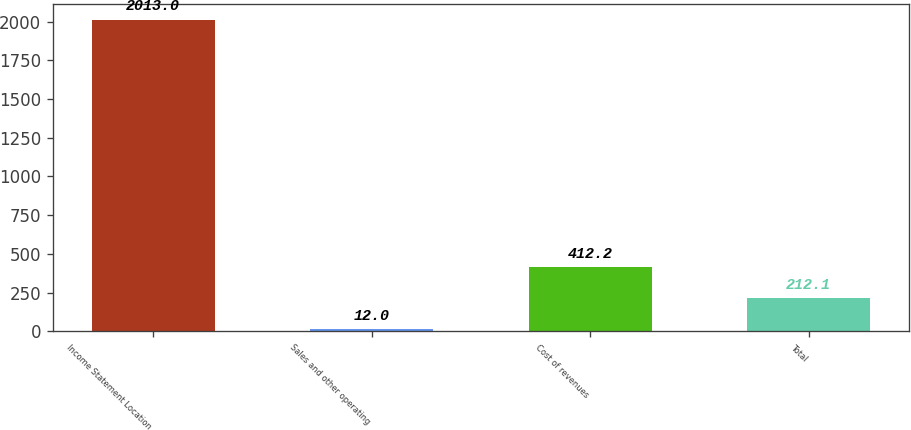Convert chart. <chart><loc_0><loc_0><loc_500><loc_500><bar_chart><fcel>Income Statement Location<fcel>Sales and other operating<fcel>Cost of revenues<fcel>Total<nl><fcel>2013<fcel>12<fcel>412.2<fcel>212.1<nl></chart> 